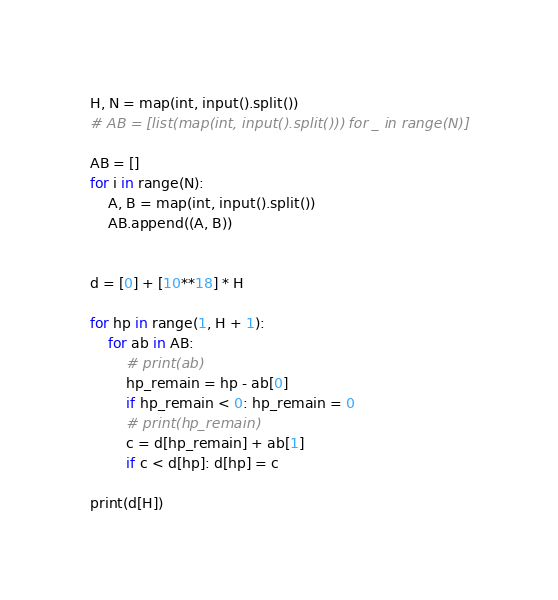Convert code to text. <code><loc_0><loc_0><loc_500><loc_500><_Python_>H, N = map(int, input().split())
# AB = [list(map(int, input().split())) for _ in range(N)]

AB = []
for i in range(N):
    A, B = map(int, input().split())
    AB.append((A, B))


d = [0] + [10**18] * H

for hp in range(1, H + 1):
    for ab in AB:
        # print(ab)
        hp_remain = hp - ab[0]
        if hp_remain < 0: hp_remain = 0
        # print(hp_remain)
        c = d[hp_remain] + ab[1]
        if c < d[hp]: d[hp] = c

print(d[H])


</code> 